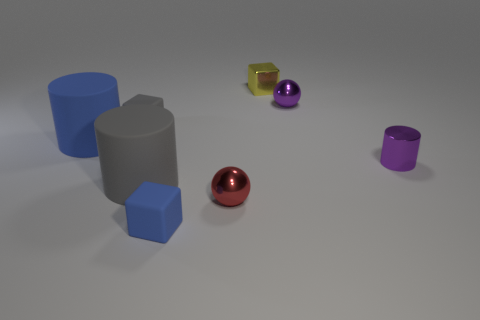Add 1 yellow cubes. How many objects exist? 9 Subtract all cylinders. How many objects are left? 5 Subtract 1 yellow blocks. How many objects are left? 7 Subtract all spheres. Subtract all small blue matte balls. How many objects are left? 6 Add 5 rubber things. How many rubber things are left? 9 Add 3 gray matte things. How many gray matte things exist? 5 